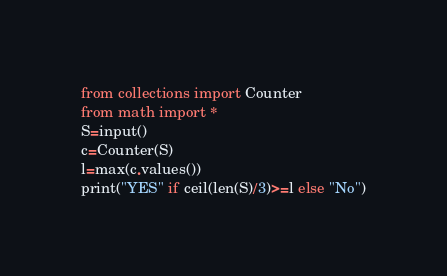<code> <loc_0><loc_0><loc_500><loc_500><_Python_>from collections import Counter
from math import *
S=input()
c=Counter(S)
l=max(c.values())
print("YES" if ceil(len(S)/3)>=l else "No")</code> 